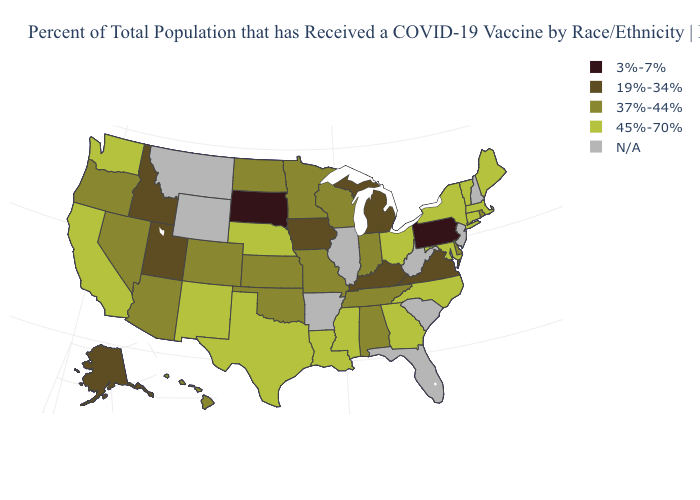Name the states that have a value in the range 19%-34%?
Quick response, please. Alaska, Idaho, Iowa, Kentucky, Michigan, Utah, Virginia. Name the states that have a value in the range 37%-44%?
Answer briefly. Alabama, Arizona, Colorado, Delaware, Hawaii, Indiana, Kansas, Minnesota, Missouri, Nevada, North Dakota, Oklahoma, Oregon, Rhode Island, Tennessee, Wisconsin. Name the states that have a value in the range 45%-70%?
Answer briefly. California, Connecticut, Georgia, Louisiana, Maine, Maryland, Massachusetts, Mississippi, Nebraska, New Mexico, New York, North Carolina, Ohio, Texas, Vermont, Washington. What is the value of Nebraska?
Concise answer only. 45%-70%. What is the lowest value in states that border Florida?
Keep it brief. 37%-44%. Among the states that border North Dakota , which have the lowest value?
Write a very short answer. South Dakota. What is the value of Vermont?
Write a very short answer. 45%-70%. What is the value of Wisconsin?
Write a very short answer. 37%-44%. What is the value of Utah?
Keep it brief. 19%-34%. What is the highest value in the South ?
Give a very brief answer. 45%-70%. Which states have the lowest value in the USA?
Give a very brief answer. Pennsylvania, South Dakota. Does the first symbol in the legend represent the smallest category?
Quick response, please. Yes. Does North Carolina have the lowest value in the South?
Keep it brief. No. Does New Mexico have the highest value in the West?
Short answer required. Yes. What is the value of Connecticut?
Give a very brief answer. 45%-70%. 